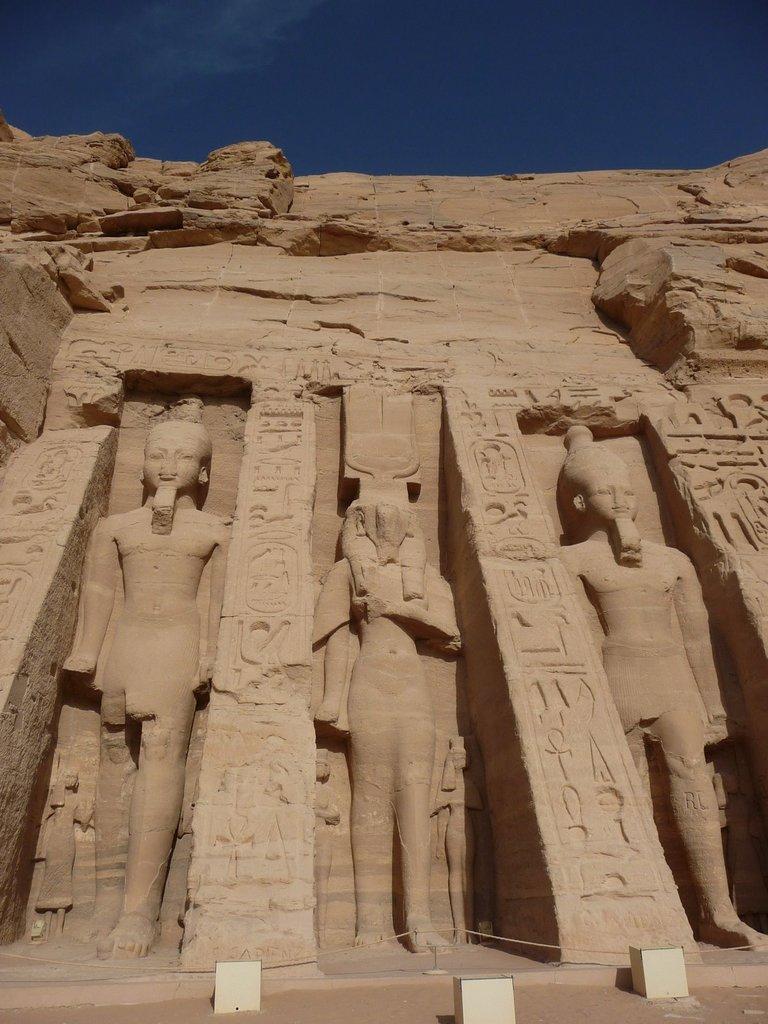In one or two sentences, can you explain what this image depicts? In this image in the center there are some sculptures, and there is a wall. At the bottom there are some boxes and walkway, at the top there is sky. 